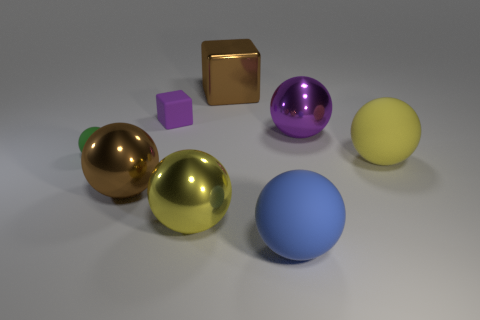What is the color of the ball that is right of the purple shiny sphere that is right of the small matte block?
Provide a succinct answer. Yellow. What number of small yellow objects are there?
Make the answer very short. 0. What number of shiny objects are either balls or gray cylinders?
Ensure brevity in your answer.  3. How many tiny things have the same color as the matte block?
Your answer should be compact. 0. What is the material of the yellow thing behind the brown object that is in front of the large purple shiny ball?
Provide a succinct answer. Rubber. What is the size of the purple cube?
Ensure brevity in your answer.  Small. How many blue rubber things are the same size as the purple rubber block?
Your answer should be very brief. 0. What number of blue things have the same shape as the small green rubber object?
Keep it short and to the point. 1. Is the number of tiny purple matte objects to the left of the big brown sphere the same as the number of big rubber blocks?
Your answer should be very brief. Yes. Are there any other things that have the same size as the green matte object?
Your answer should be very brief. Yes. 